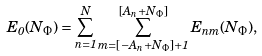<formula> <loc_0><loc_0><loc_500><loc_500>E _ { 0 } ( N _ { \Phi } ) = \sum _ { n = 1 } ^ { N } \sum _ { m = \left [ - A _ { n } + N _ { \Phi } \right ] + 1 } ^ { \left [ A _ { n } + N _ { \Phi } \right ] } E _ { n m } ( N _ { \Phi } ) ,</formula> 